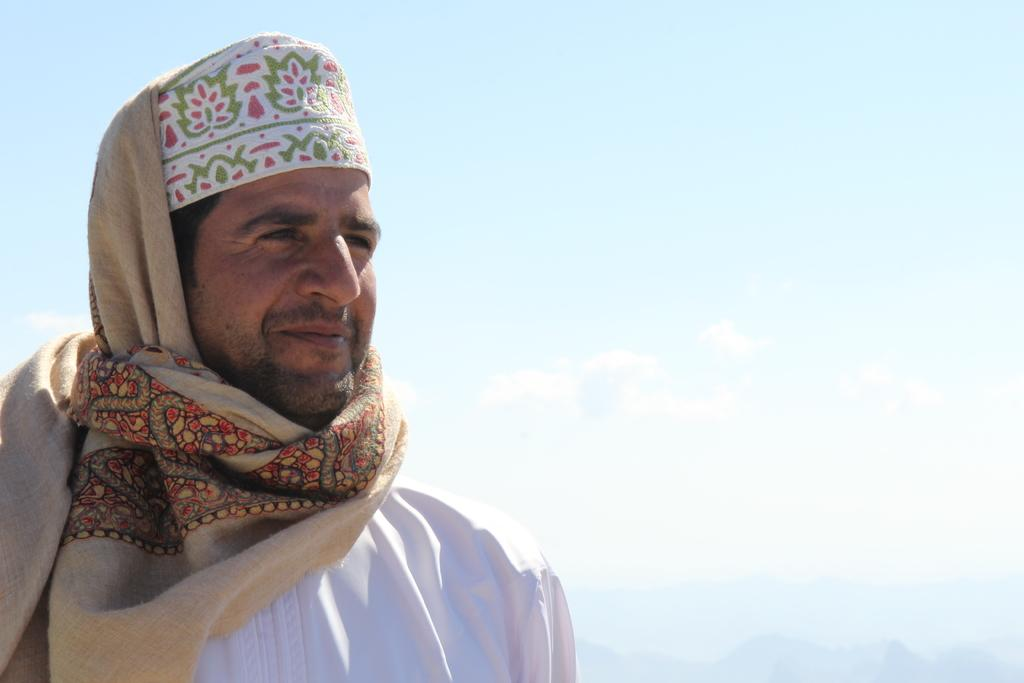Who is present in the image? There is a man in the image. What is the man wearing around his neck? The man is wearing a scarf. What is the man wearing on his head? The man is wearing a cap. What can be seen in the background of the image? There is sky visible in the image. What type of potato is the man holding in the image? There is no potato present in the image; the man is not holding any potato. 